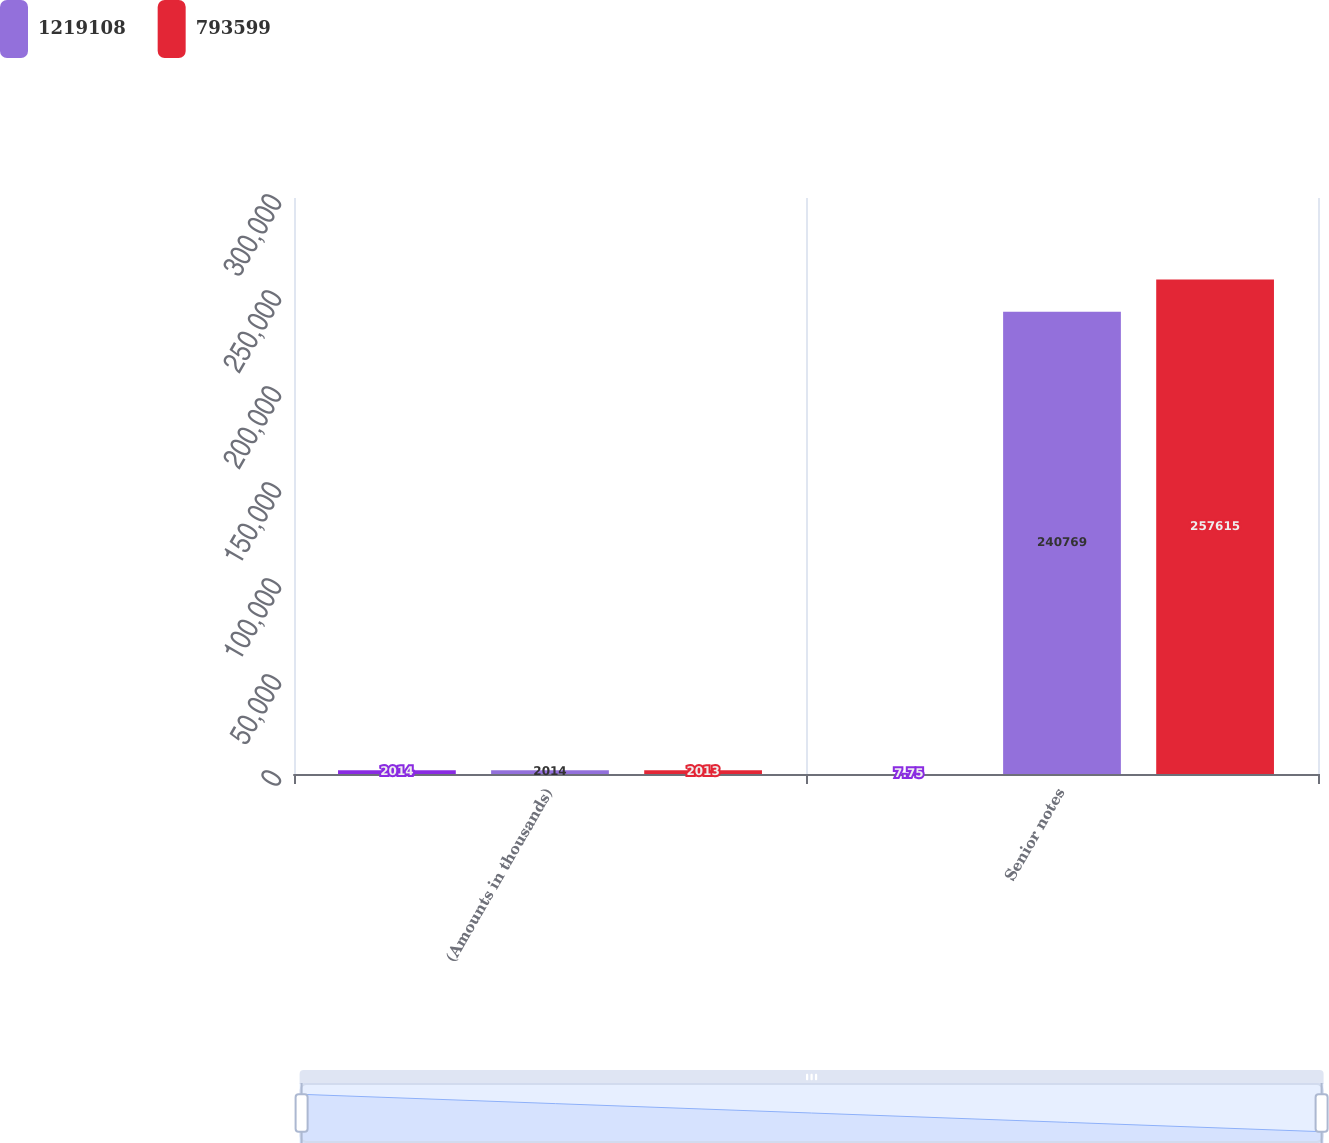Convert chart. <chart><loc_0><loc_0><loc_500><loc_500><stacked_bar_chart><ecel><fcel>(Amounts in thousands)<fcel>Senior notes<nl><fcel>nan<fcel>2014<fcel>7.75<nl><fcel>1.21911e+06<fcel>2014<fcel>240769<nl><fcel>793599<fcel>2013<fcel>257615<nl></chart> 